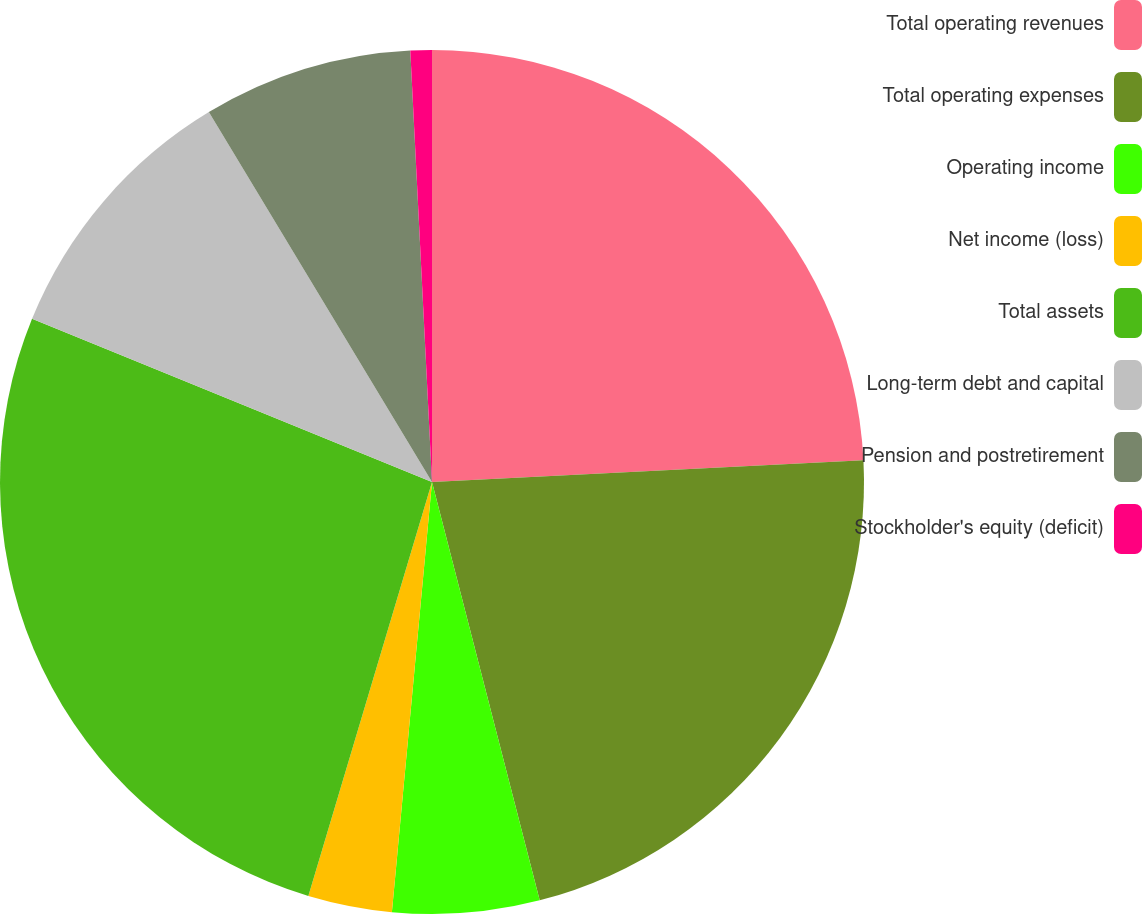Convert chart. <chart><loc_0><loc_0><loc_500><loc_500><pie_chart><fcel>Total operating revenues<fcel>Total operating expenses<fcel>Operating income<fcel>Net income (loss)<fcel>Total assets<fcel>Long-term debt and capital<fcel>Pension and postretirement<fcel>Stockholder's equity (deficit)<nl><fcel>24.2%<fcel>21.79%<fcel>5.49%<fcel>3.14%<fcel>26.55%<fcel>10.19%<fcel>7.84%<fcel>0.8%<nl></chart> 